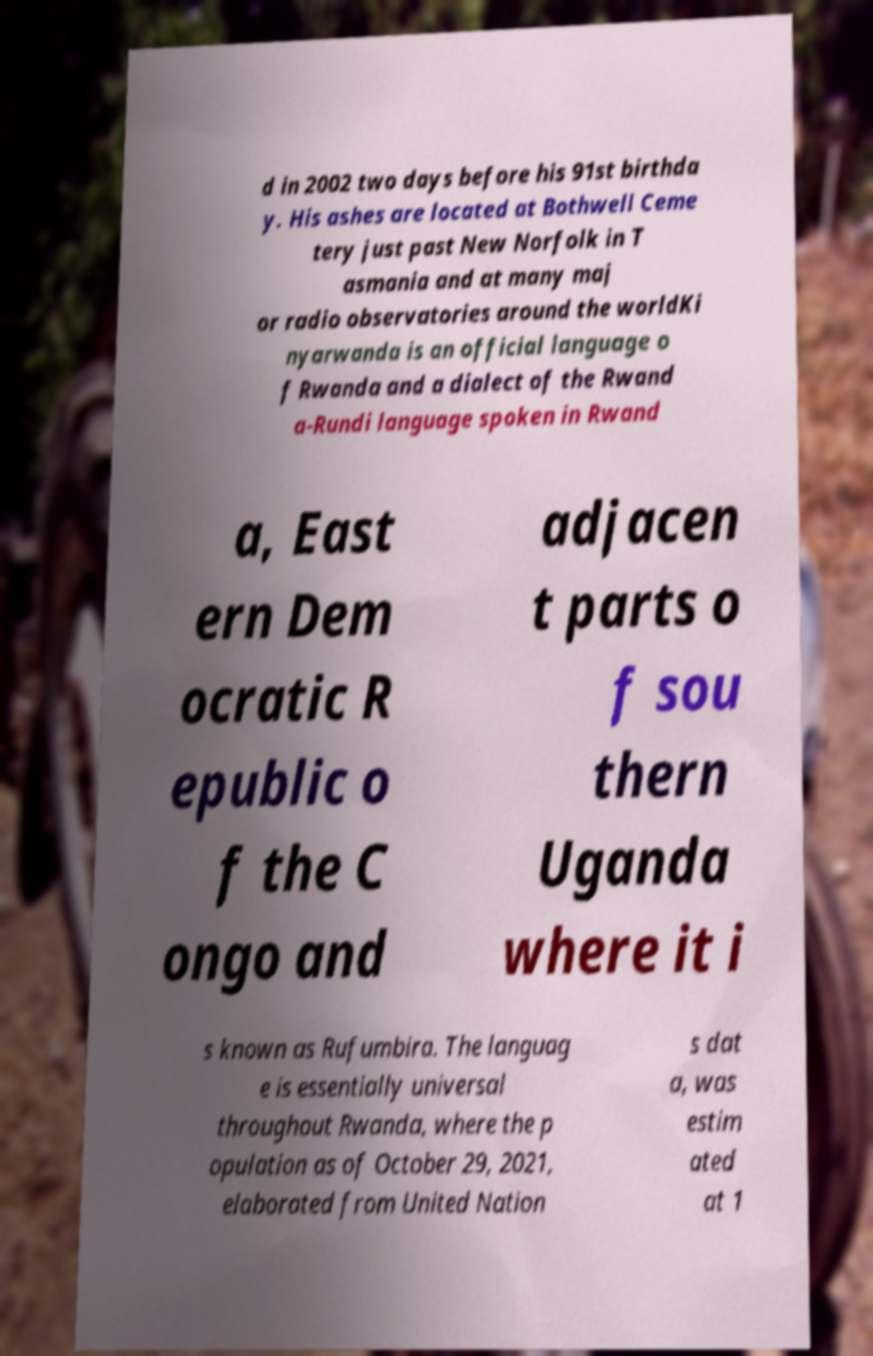Could you assist in decoding the text presented in this image and type it out clearly? d in 2002 two days before his 91st birthda y. His ashes are located at Bothwell Ceme tery just past New Norfolk in T asmania and at many maj or radio observatories around the worldKi nyarwanda is an official language o f Rwanda and a dialect of the Rwand a-Rundi language spoken in Rwand a, East ern Dem ocratic R epublic o f the C ongo and adjacen t parts o f sou thern Uganda where it i s known as Rufumbira. The languag e is essentially universal throughout Rwanda, where the p opulation as of October 29, 2021, elaborated from United Nation s dat a, was estim ated at 1 